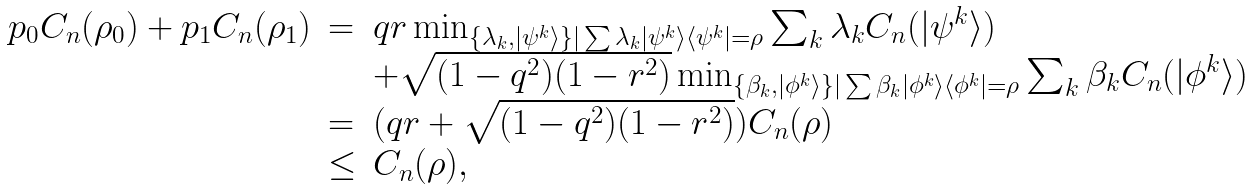Convert formula to latex. <formula><loc_0><loc_0><loc_500><loc_500>\begin{array} { l l l } p _ { 0 } C _ { n } ( \rho _ { 0 } ) + p _ { 1 } C _ { n } ( \rho _ { 1 } ) & = & q r \min _ { \{ \lambda _ { k } , | \psi ^ { k } \rangle \} | \sum { \lambda _ { k } | \psi ^ { k } \rangle \langle \psi ^ { k } | = \rho } } \sum _ { k } \lambda _ { k } C _ { n } ( | \psi ^ { k } \rangle ) \\ & & + \sqrt { ( 1 - q ^ { 2 } ) ( 1 - r ^ { 2 } ) } \min _ { \{ \beta _ { k } , | \phi ^ { k } \rangle \} | \sum { \beta _ { k } | \phi ^ { k } \rangle \langle \phi ^ { k } | = \rho } } \sum _ { k } \beta _ { k } C _ { n } ( | \phi ^ { k } \rangle ) \\ & = & ( q r + \sqrt { ( 1 - q ^ { 2 } ) ( 1 - r ^ { 2 } ) } ) C _ { n } ( \rho ) \\ & \leq & C _ { n } ( \rho ) , \, \end{array}</formula> 